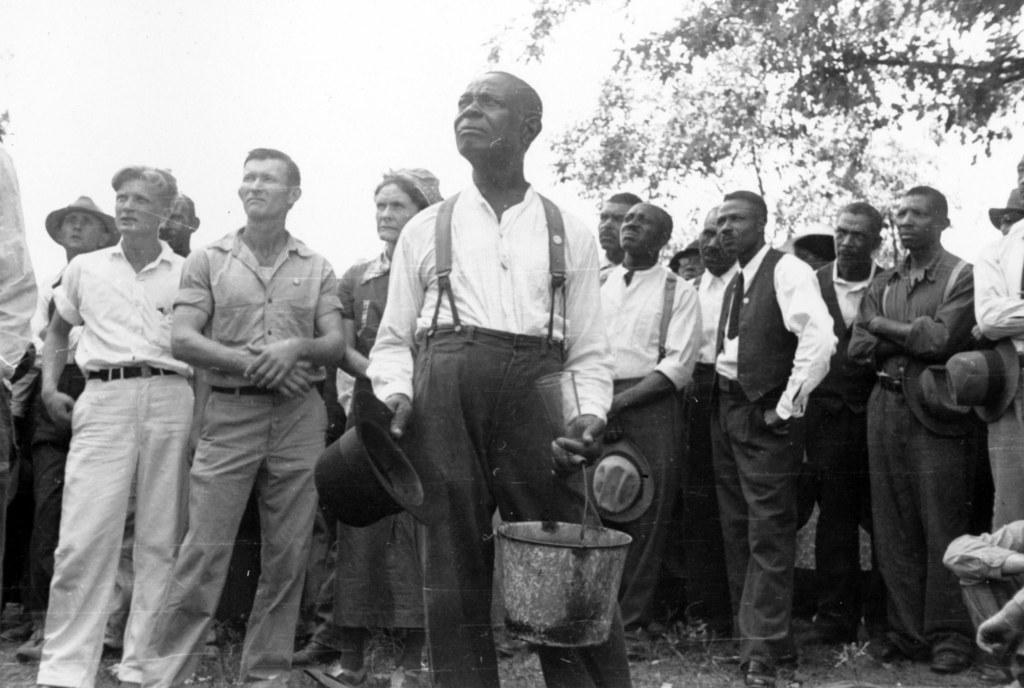Describe this image in one or two sentences. This looks like a black and white image. Here is the man standing and holding a hat and a bucket. There are group of people standing. This looks like a tree. 